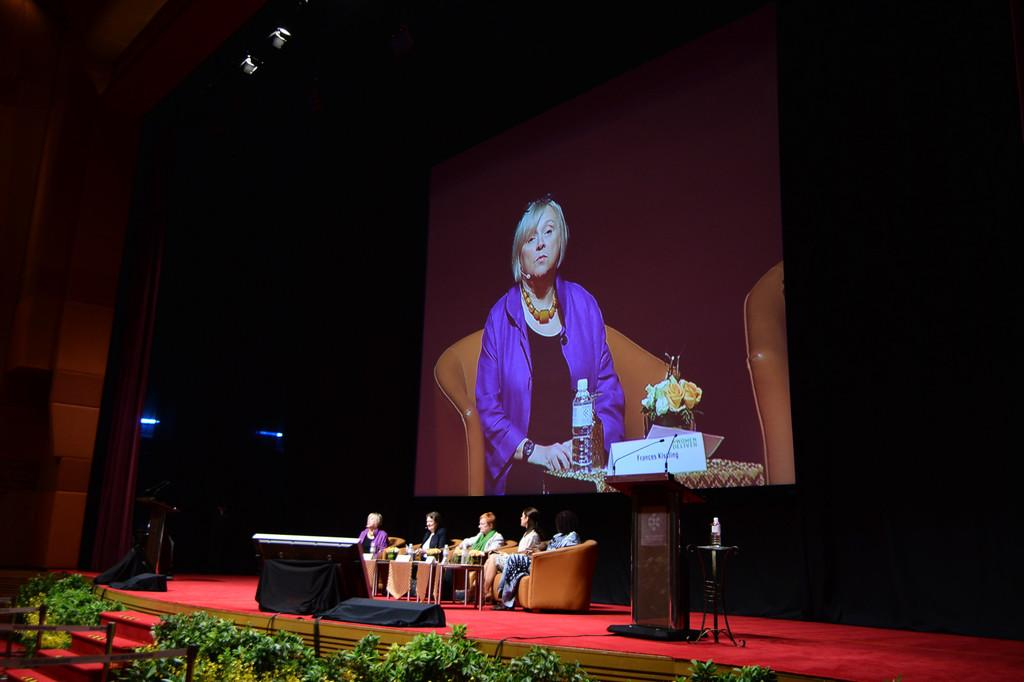What are the people in the image doing? The people in the image are sitting on sofas. What color is the carpet in the image? The carpet in the image is red. What type of vegetation is present in the image? There are green plants in the image. What card game is being played on the red carpet in the image? There is no card game or cards present in the image; it only shows people sitting on sofas and green plants. Is the queen present in the image? There is no reference to a queen or any royal figure in the image. 